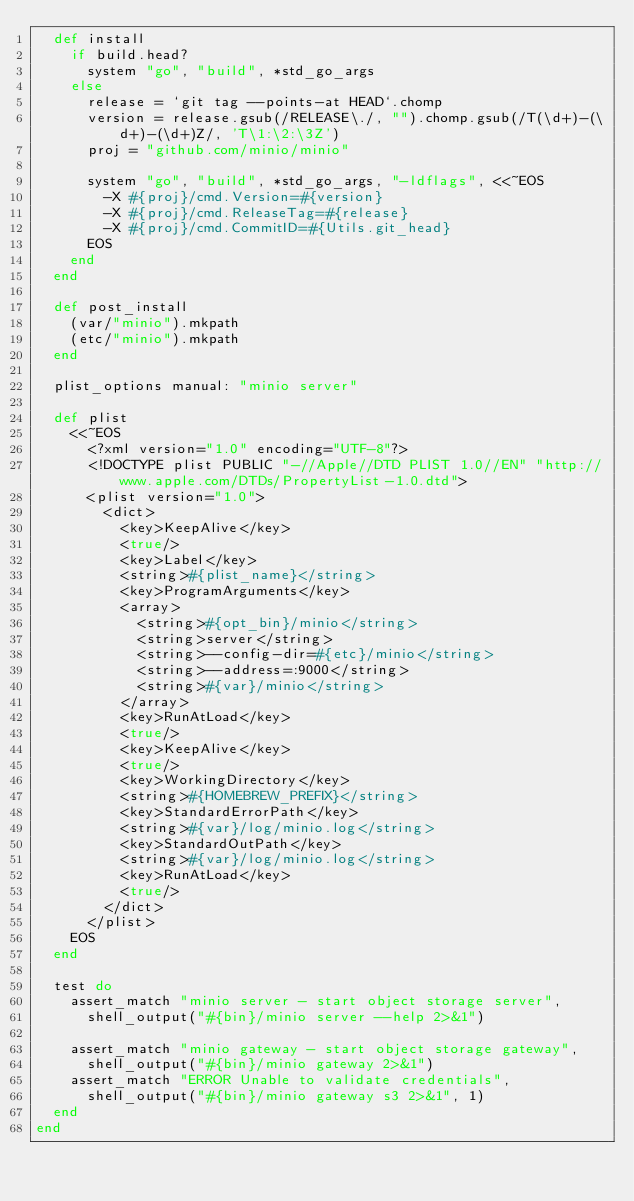<code> <loc_0><loc_0><loc_500><loc_500><_Ruby_>  def install
    if build.head?
      system "go", "build", *std_go_args
    else
      release = `git tag --points-at HEAD`.chomp
      version = release.gsub(/RELEASE\./, "").chomp.gsub(/T(\d+)-(\d+)-(\d+)Z/, 'T\1:\2:\3Z')
      proj = "github.com/minio/minio"

      system "go", "build", *std_go_args, "-ldflags", <<~EOS
        -X #{proj}/cmd.Version=#{version}
        -X #{proj}/cmd.ReleaseTag=#{release}
        -X #{proj}/cmd.CommitID=#{Utils.git_head}
      EOS
    end
  end

  def post_install
    (var/"minio").mkpath
    (etc/"minio").mkpath
  end

  plist_options manual: "minio server"

  def plist
    <<~EOS
      <?xml version="1.0" encoding="UTF-8"?>
      <!DOCTYPE plist PUBLIC "-//Apple//DTD PLIST 1.0//EN" "http://www.apple.com/DTDs/PropertyList-1.0.dtd">
      <plist version="1.0">
        <dict>
          <key>KeepAlive</key>
          <true/>
          <key>Label</key>
          <string>#{plist_name}</string>
          <key>ProgramArguments</key>
          <array>
            <string>#{opt_bin}/minio</string>
            <string>server</string>
            <string>--config-dir=#{etc}/minio</string>
            <string>--address=:9000</string>
            <string>#{var}/minio</string>
          </array>
          <key>RunAtLoad</key>
          <true/>
          <key>KeepAlive</key>
          <true/>
          <key>WorkingDirectory</key>
          <string>#{HOMEBREW_PREFIX}</string>
          <key>StandardErrorPath</key>
          <string>#{var}/log/minio.log</string>
          <key>StandardOutPath</key>
          <string>#{var}/log/minio.log</string>
          <key>RunAtLoad</key>
          <true/>
        </dict>
      </plist>
    EOS
  end

  test do
    assert_match "minio server - start object storage server",
      shell_output("#{bin}/minio server --help 2>&1")

    assert_match "minio gateway - start object storage gateway",
      shell_output("#{bin}/minio gateway 2>&1")
    assert_match "ERROR Unable to validate credentials",
      shell_output("#{bin}/minio gateway s3 2>&1", 1)
  end
end
</code> 